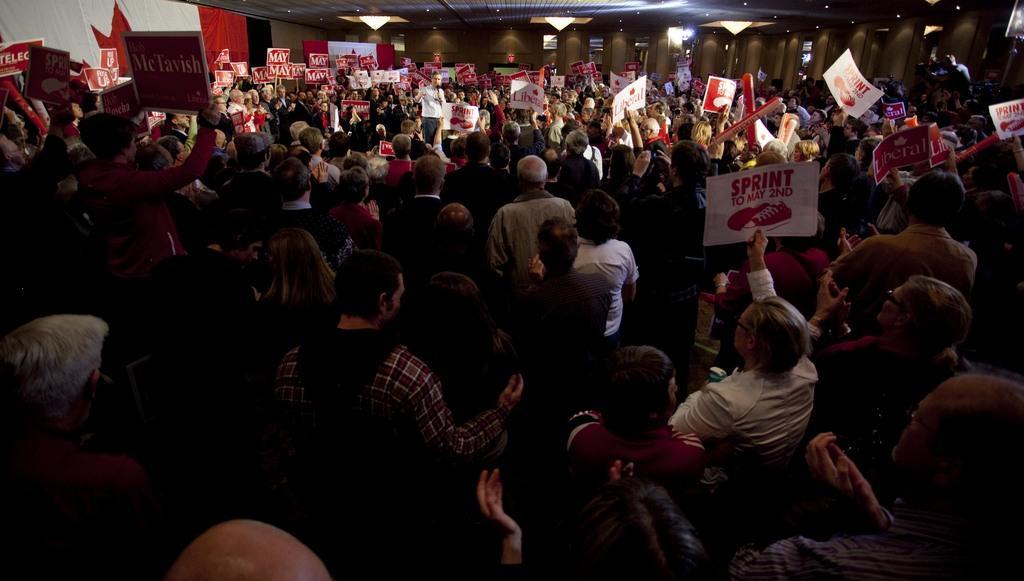How would you summarize this image in a sentence or two? In this image I can see the group of people with different color dresses. I can see few people are holding the boards and papers. These boards are in red and white color. To the left I can see red and white color banner. In the top there are many lights and the ceiling. 